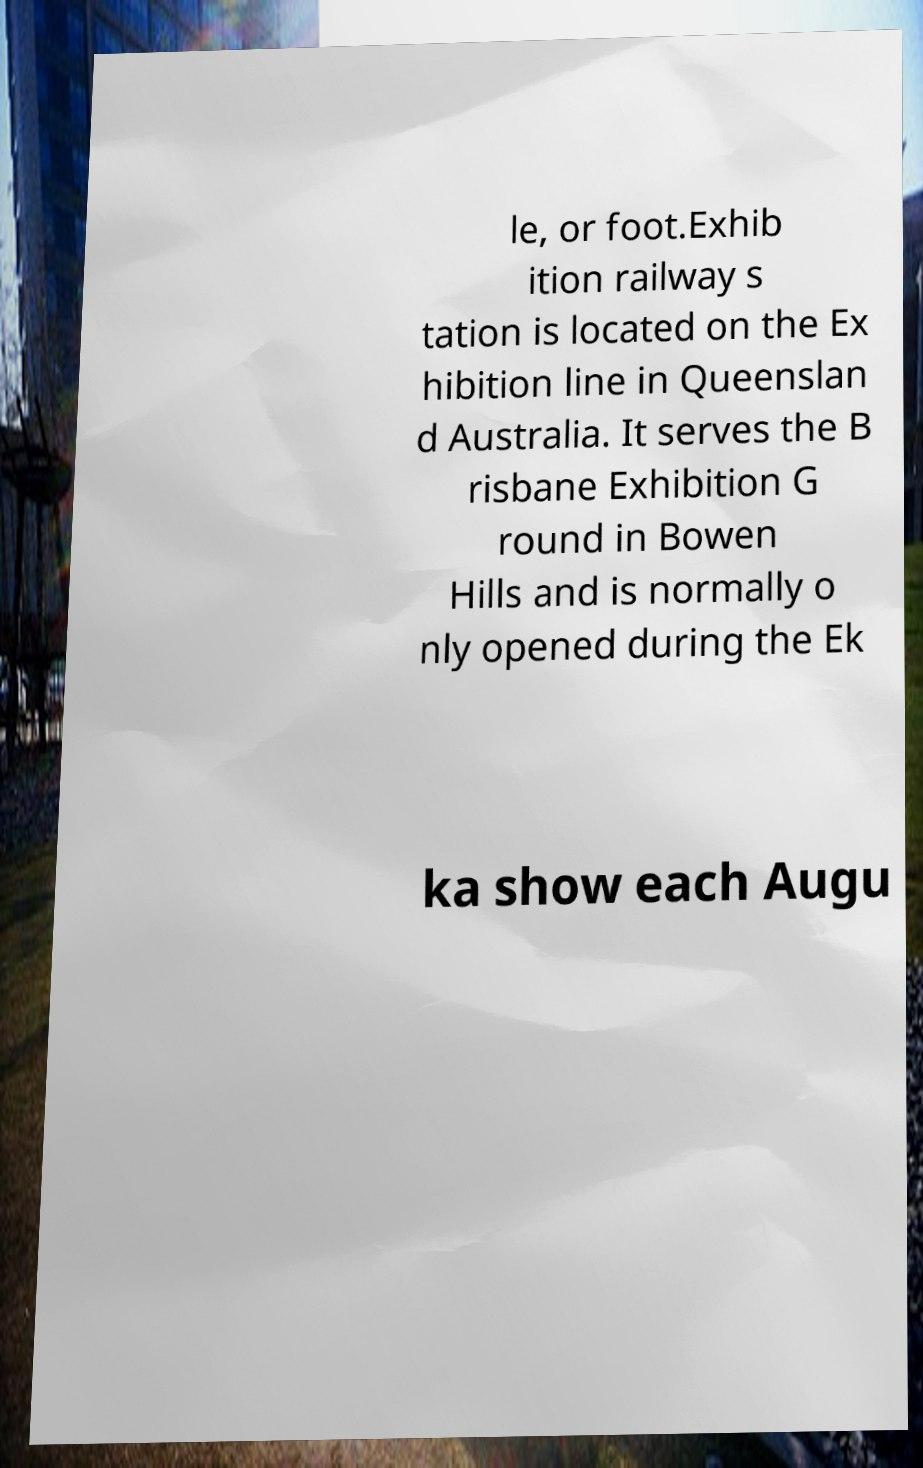Please read and relay the text visible in this image. What does it say? le, or foot.Exhib ition railway s tation is located on the Ex hibition line in Queenslan d Australia. It serves the B risbane Exhibition G round in Bowen Hills and is normally o nly opened during the Ek ka show each Augu 